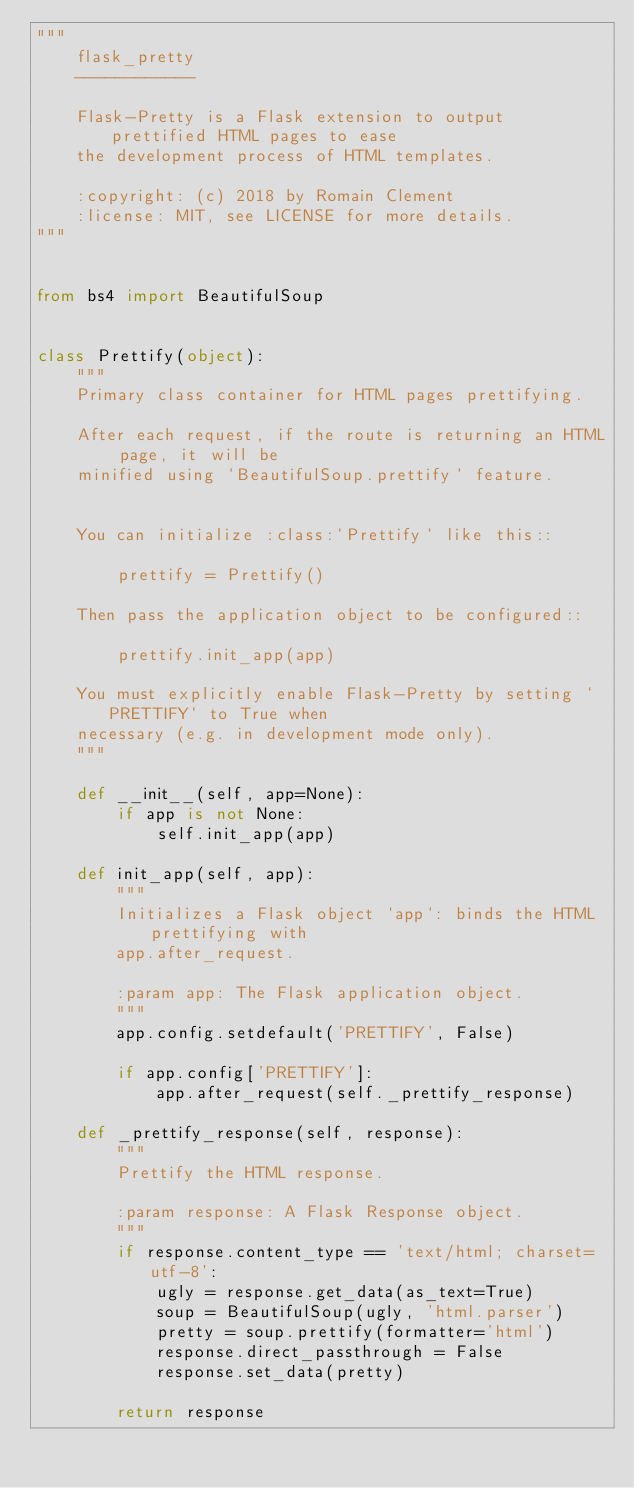<code> <loc_0><loc_0><loc_500><loc_500><_Python_>"""
    flask_pretty
    ------------

    Flask-Pretty is a Flask extension to output prettified HTML pages to ease
    the development process of HTML templates.

    :copyright: (c) 2018 by Romain Clement
    :license: MIT, see LICENSE for more details.
"""


from bs4 import BeautifulSoup


class Prettify(object):
    """
    Primary class container for HTML pages prettifying.

    After each request, if the route is returning an HTML page, it will be
    minified using `BeautifulSoup.prettify` feature.


    You can initialize :class:`Prettify` like this::

        prettify = Prettify()

    Then pass the application object to be configured::

        prettify.init_app(app)

    You must explicitly enable Flask-Pretty by setting `PRETTIFY` to True when
    necessary (e.g. in development mode only).
    """

    def __init__(self, app=None):
        if app is not None:
            self.init_app(app)

    def init_app(self, app):
        """
        Initializes a Flask object `app`: binds the HTML prettifying with
        app.after_request.

        :param app: The Flask application object.
        """
        app.config.setdefault('PRETTIFY', False)

        if app.config['PRETTIFY']:
            app.after_request(self._prettify_response)

    def _prettify_response(self, response):
        """
        Prettify the HTML response.

        :param response: A Flask Response object.
        """
        if response.content_type == 'text/html; charset=utf-8':
            ugly = response.get_data(as_text=True)
            soup = BeautifulSoup(ugly, 'html.parser')
            pretty = soup.prettify(formatter='html')
            response.direct_passthrough = False
            response.set_data(pretty)

        return response
</code> 